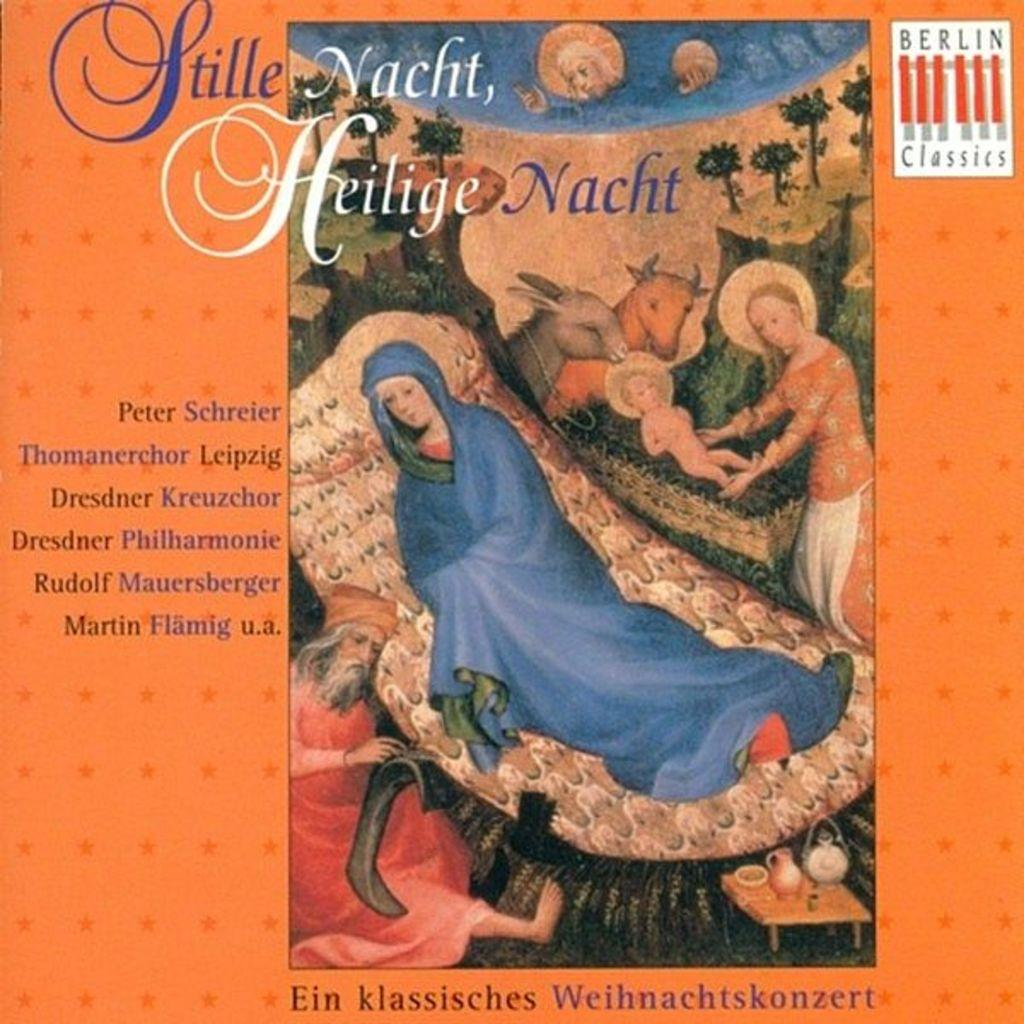<image>
Relay a brief, clear account of the picture shown. A book called Stille Nacht, Heilige Nacht written by Peter Schreier and other authors. 